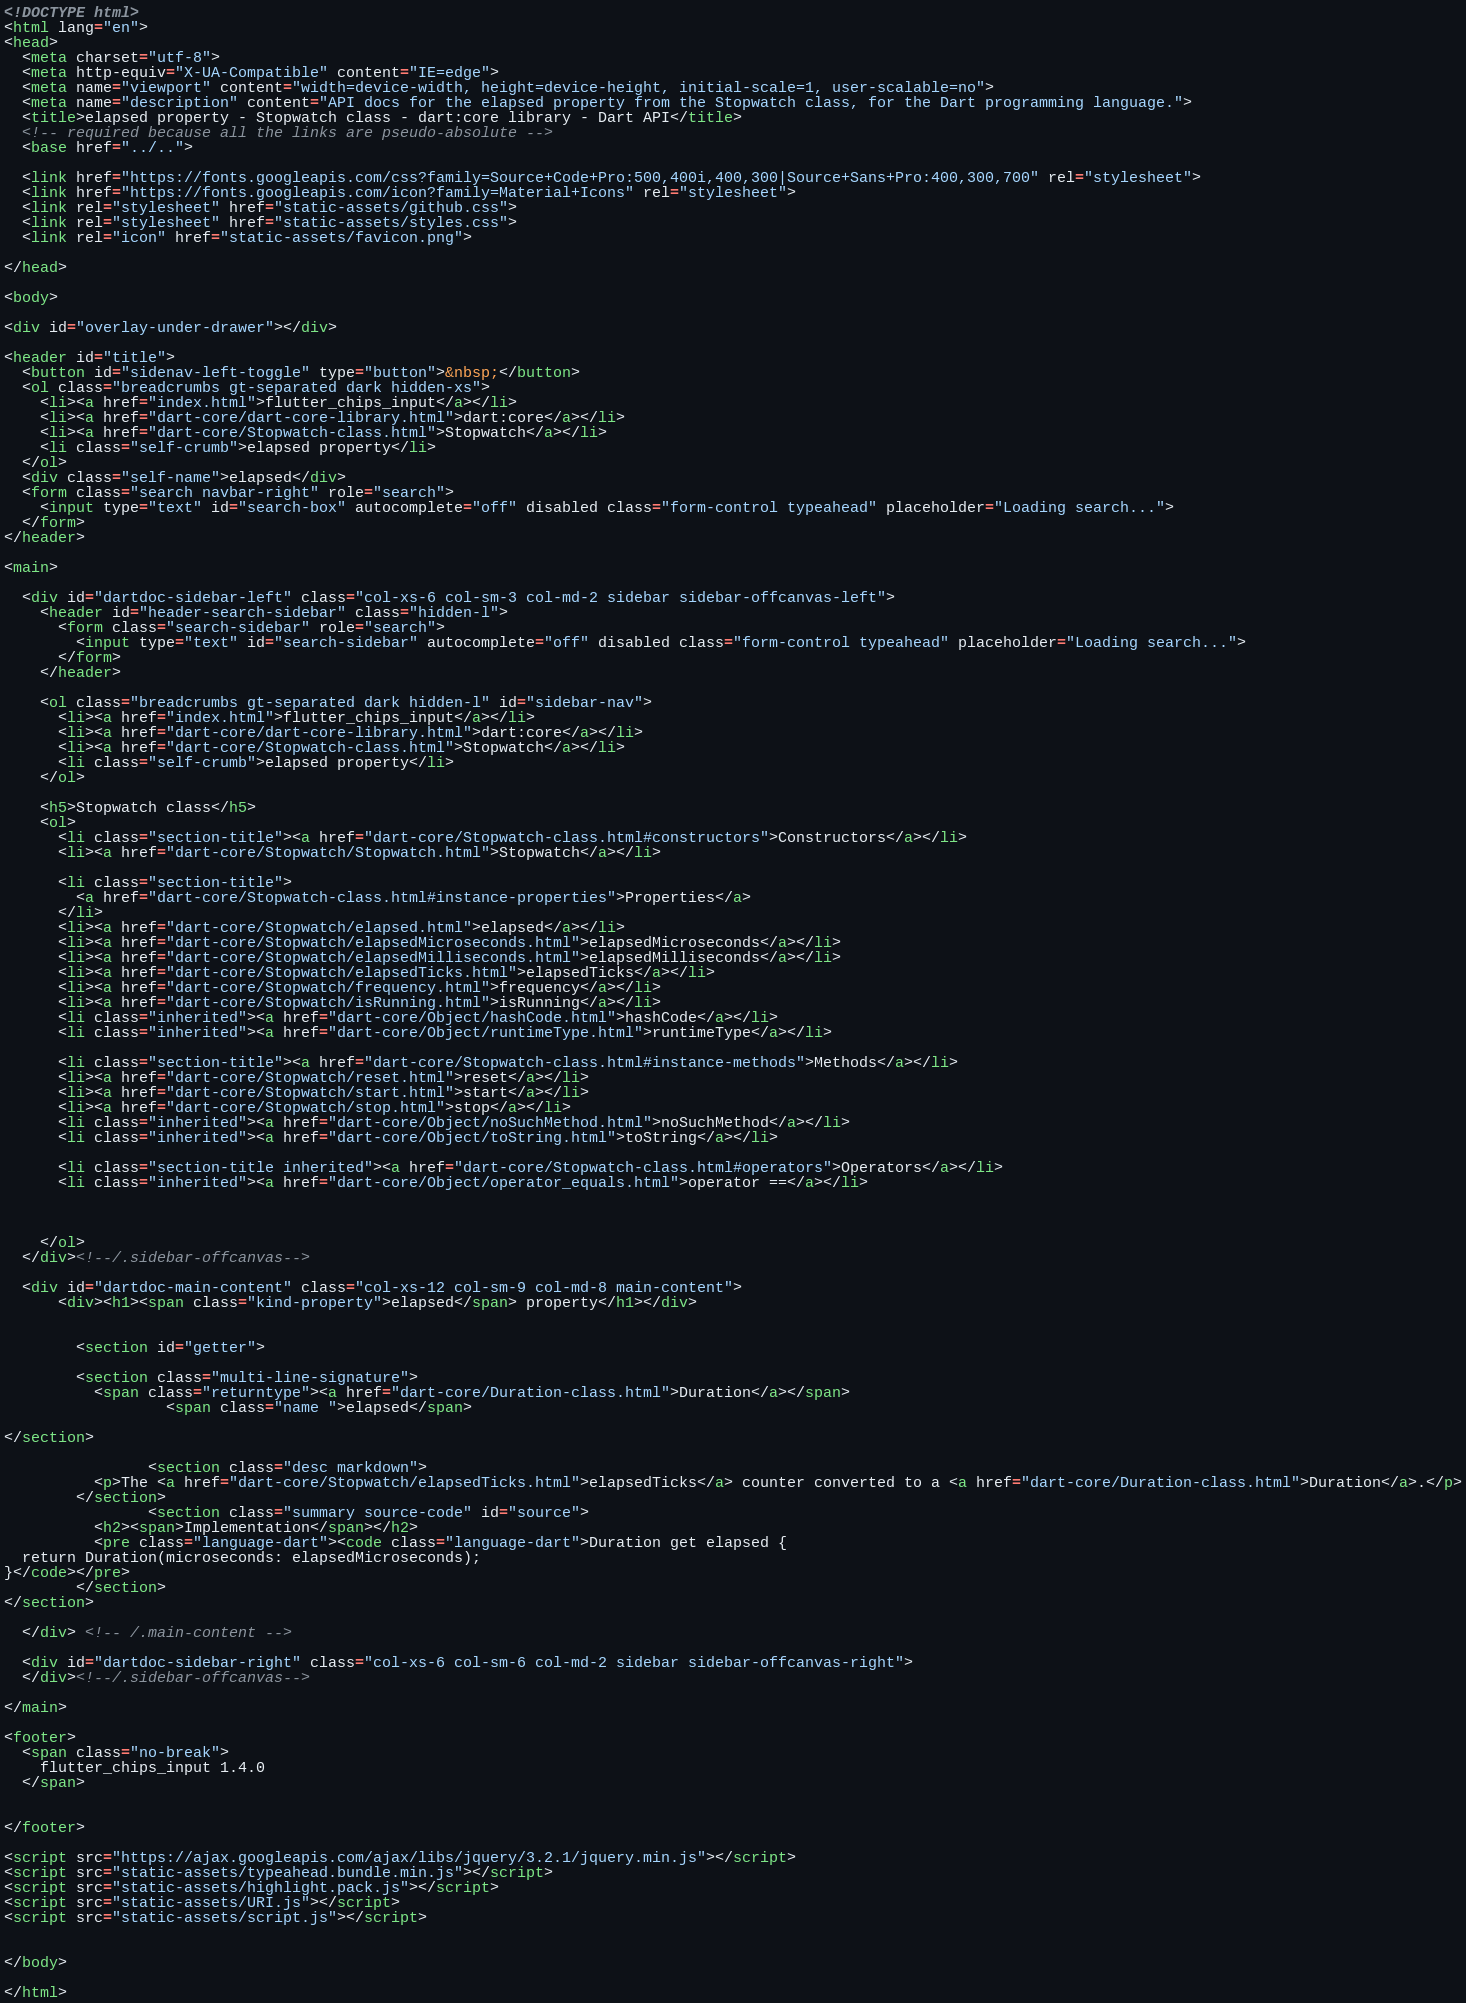Convert code to text. <code><loc_0><loc_0><loc_500><loc_500><_HTML_><!DOCTYPE html>
<html lang="en">
<head>
  <meta charset="utf-8">
  <meta http-equiv="X-UA-Compatible" content="IE=edge">
  <meta name="viewport" content="width=device-width, height=device-height, initial-scale=1, user-scalable=no">
  <meta name="description" content="API docs for the elapsed property from the Stopwatch class, for the Dart programming language.">
  <title>elapsed property - Stopwatch class - dart:core library - Dart API</title>
  <!-- required because all the links are pseudo-absolute -->
  <base href="../..">

  <link href="https://fonts.googleapis.com/css?family=Source+Code+Pro:500,400i,400,300|Source+Sans+Pro:400,300,700" rel="stylesheet">
  <link href="https://fonts.googleapis.com/icon?family=Material+Icons" rel="stylesheet">
  <link rel="stylesheet" href="static-assets/github.css">
  <link rel="stylesheet" href="static-assets/styles.css">
  <link rel="icon" href="static-assets/favicon.png">
  
</head>

<body>

<div id="overlay-under-drawer"></div>

<header id="title">
  <button id="sidenav-left-toggle" type="button">&nbsp;</button>
  <ol class="breadcrumbs gt-separated dark hidden-xs">
    <li><a href="index.html">flutter_chips_input</a></li>
    <li><a href="dart-core/dart-core-library.html">dart:core</a></li>
    <li><a href="dart-core/Stopwatch-class.html">Stopwatch</a></li>
    <li class="self-crumb">elapsed property</li>
  </ol>
  <div class="self-name">elapsed</div>
  <form class="search navbar-right" role="search">
    <input type="text" id="search-box" autocomplete="off" disabled class="form-control typeahead" placeholder="Loading search...">
  </form>
</header>

<main>

  <div id="dartdoc-sidebar-left" class="col-xs-6 col-sm-3 col-md-2 sidebar sidebar-offcanvas-left">
    <header id="header-search-sidebar" class="hidden-l">
      <form class="search-sidebar" role="search">
        <input type="text" id="search-sidebar" autocomplete="off" disabled class="form-control typeahead" placeholder="Loading search...">
      </form>
    </header>
    
    <ol class="breadcrumbs gt-separated dark hidden-l" id="sidebar-nav">
      <li><a href="index.html">flutter_chips_input</a></li>
      <li><a href="dart-core/dart-core-library.html">dart:core</a></li>
      <li><a href="dart-core/Stopwatch-class.html">Stopwatch</a></li>
      <li class="self-crumb">elapsed property</li>
    </ol>
    
    <h5>Stopwatch class</h5>
    <ol>
      <li class="section-title"><a href="dart-core/Stopwatch-class.html#constructors">Constructors</a></li>
      <li><a href="dart-core/Stopwatch/Stopwatch.html">Stopwatch</a></li>
    
      <li class="section-title">
        <a href="dart-core/Stopwatch-class.html#instance-properties">Properties</a>
      </li>
      <li><a href="dart-core/Stopwatch/elapsed.html">elapsed</a></li>
      <li><a href="dart-core/Stopwatch/elapsedMicroseconds.html">elapsedMicroseconds</a></li>
      <li><a href="dart-core/Stopwatch/elapsedMilliseconds.html">elapsedMilliseconds</a></li>
      <li><a href="dart-core/Stopwatch/elapsedTicks.html">elapsedTicks</a></li>
      <li><a href="dart-core/Stopwatch/frequency.html">frequency</a></li>
      <li><a href="dart-core/Stopwatch/isRunning.html">isRunning</a></li>
      <li class="inherited"><a href="dart-core/Object/hashCode.html">hashCode</a></li>
      <li class="inherited"><a href="dart-core/Object/runtimeType.html">runtimeType</a></li>
    
      <li class="section-title"><a href="dart-core/Stopwatch-class.html#instance-methods">Methods</a></li>
      <li><a href="dart-core/Stopwatch/reset.html">reset</a></li>
      <li><a href="dart-core/Stopwatch/start.html">start</a></li>
      <li><a href="dart-core/Stopwatch/stop.html">stop</a></li>
      <li class="inherited"><a href="dart-core/Object/noSuchMethod.html">noSuchMethod</a></li>
      <li class="inherited"><a href="dart-core/Object/toString.html">toString</a></li>
    
      <li class="section-title inherited"><a href="dart-core/Stopwatch-class.html#operators">Operators</a></li>
      <li class="inherited"><a href="dart-core/Object/operator_equals.html">operator ==</a></li>
    
    
    
    </ol>
  </div><!--/.sidebar-offcanvas-->

  <div id="dartdoc-main-content" class="col-xs-12 col-sm-9 col-md-8 main-content">
      <div><h1><span class="kind-property">elapsed</span> property</h1></div>


        <section id="getter">
        
        <section class="multi-line-signature">
          <span class="returntype"><a href="dart-core/Duration-class.html">Duration</a></span>
                  <span class="name ">elapsed</span>
          
</section>
        
                <section class="desc markdown">
          <p>The <a href="dart-core/Stopwatch/elapsedTicks.html">elapsedTicks</a> counter converted to a <a href="dart-core/Duration-class.html">Duration</a>.</p>
        </section>
                <section class="summary source-code" id="source">
          <h2><span>Implementation</span></h2>
          <pre class="language-dart"><code class="language-dart">Duration get elapsed {
  return Duration(microseconds: elapsedMicroseconds);
}</code></pre>
        </section>
</section>
        
  </div> <!-- /.main-content -->

  <div id="dartdoc-sidebar-right" class="col-xs-6 col-sm-6 col-md-2 sidebar sidebar-offcanvas-right">
  </div><!--/.sidebar-offcanvas-->

</main>

<footer>
  <span class="no-break">
    flutter_chips_input 1.4.0
  </span>

  
</footer>

<script src="https://ajax.googleapis.com/ajax/libs/jquery/3.2.1/jquery.min.js"></script>
<script src="static-assets/typeahead.bundle.min.js"></script>
<script src="static-assets/highlight.pack.js"></script>
<script src="static-assets/URI.js"></script>
<script src="static-assets/script.js"></script>


</body>

</html>
</code> 